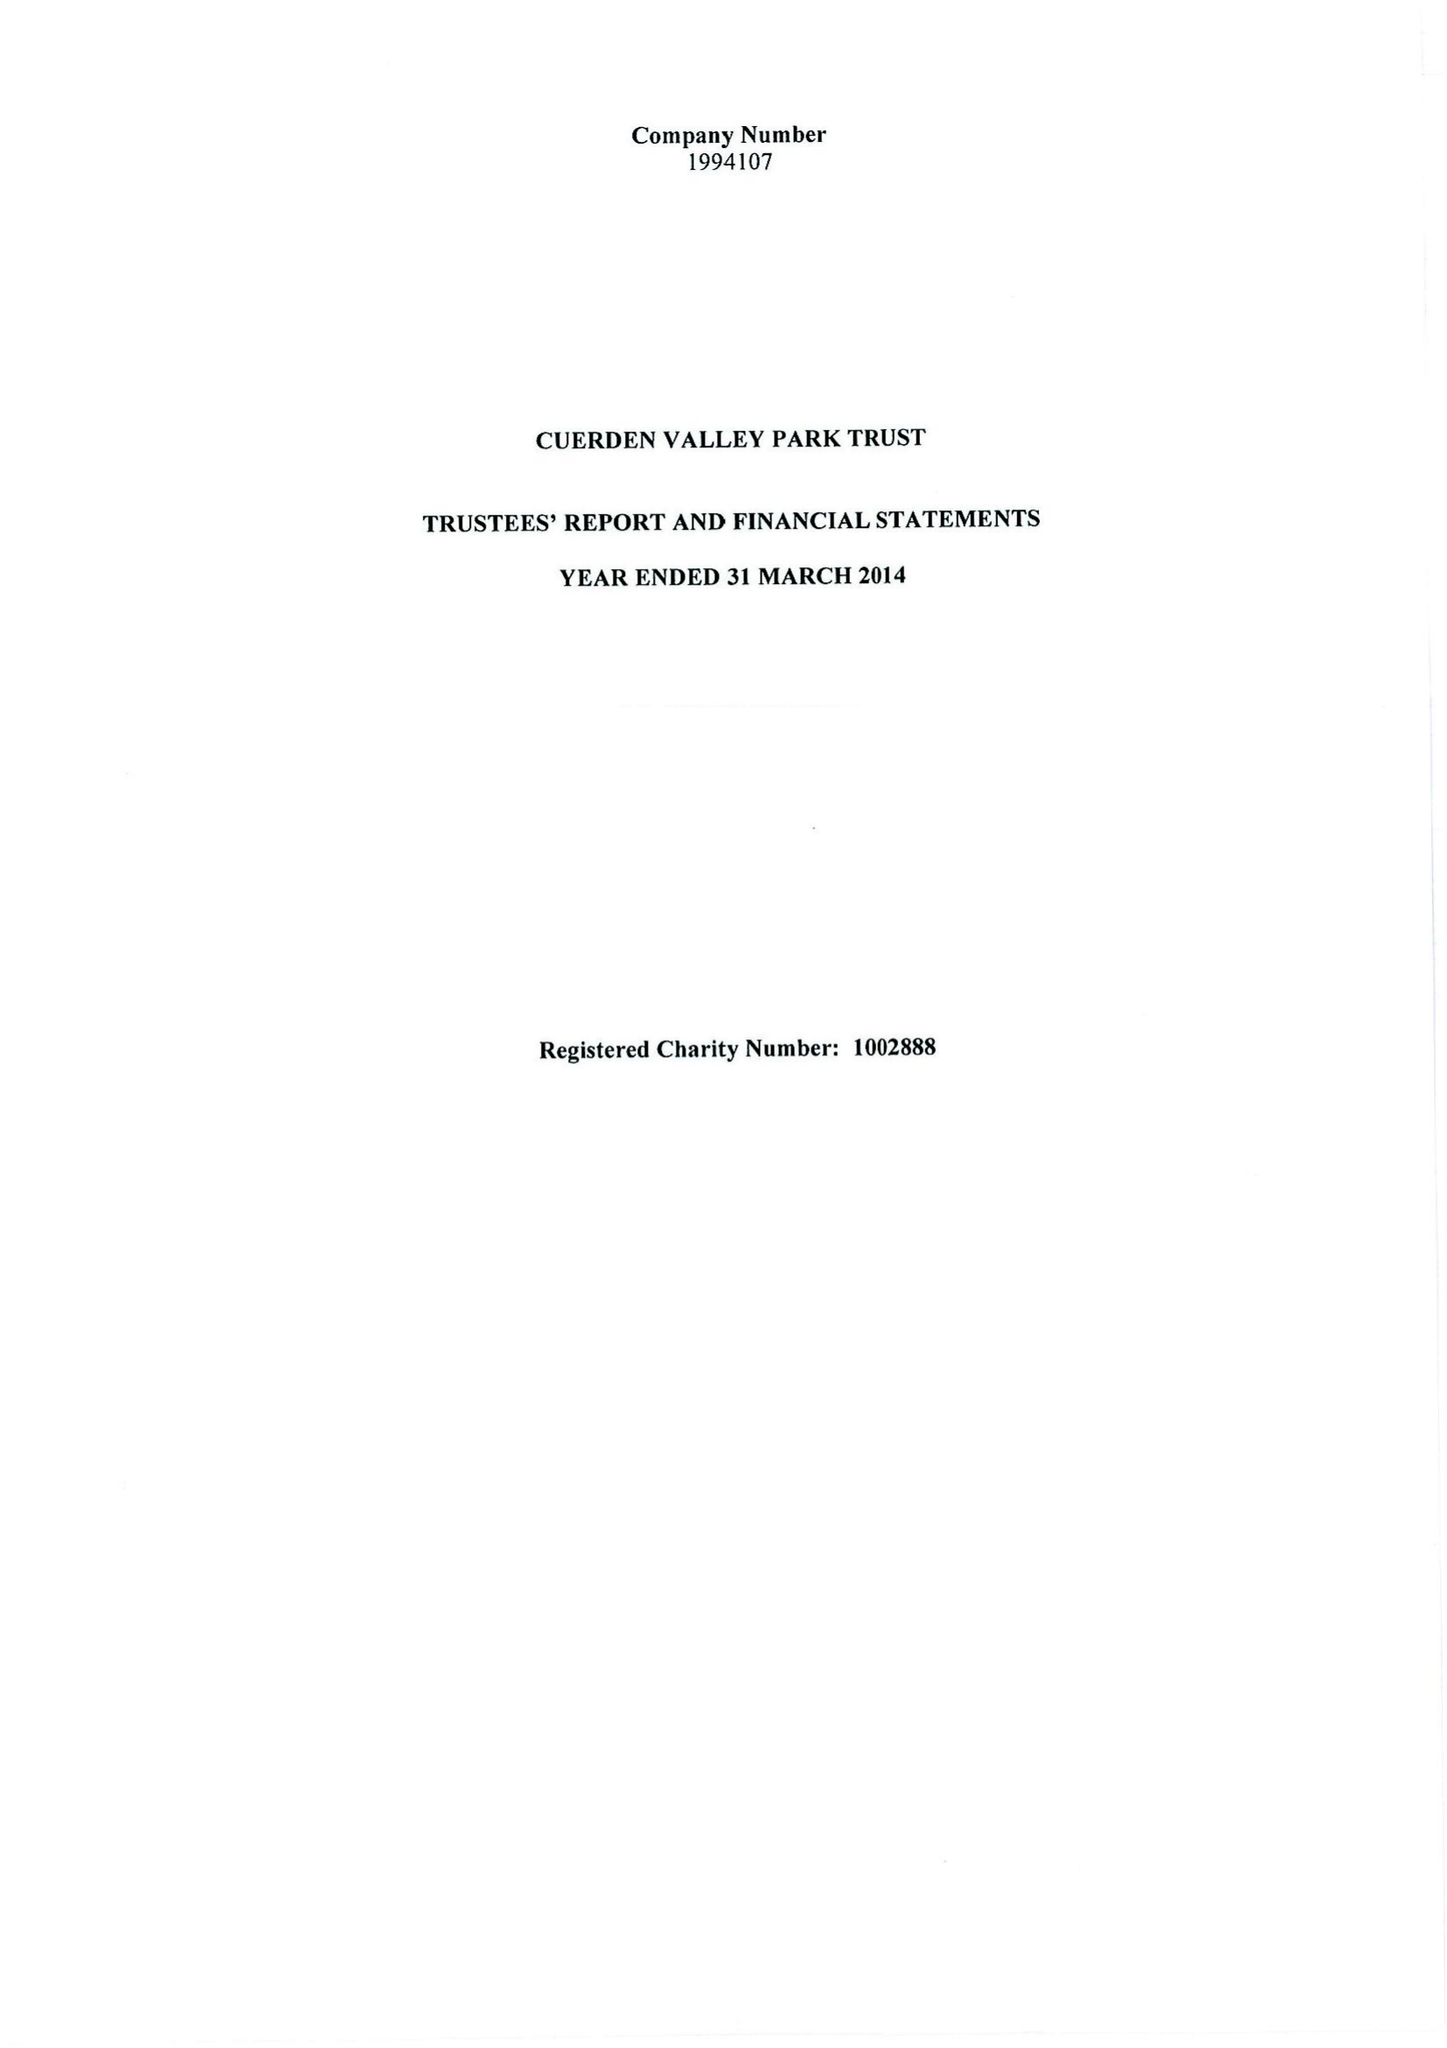What is the value for the spending_annually_in_british_pounds?
Answer the question using a single word or phrase. 300942.00 